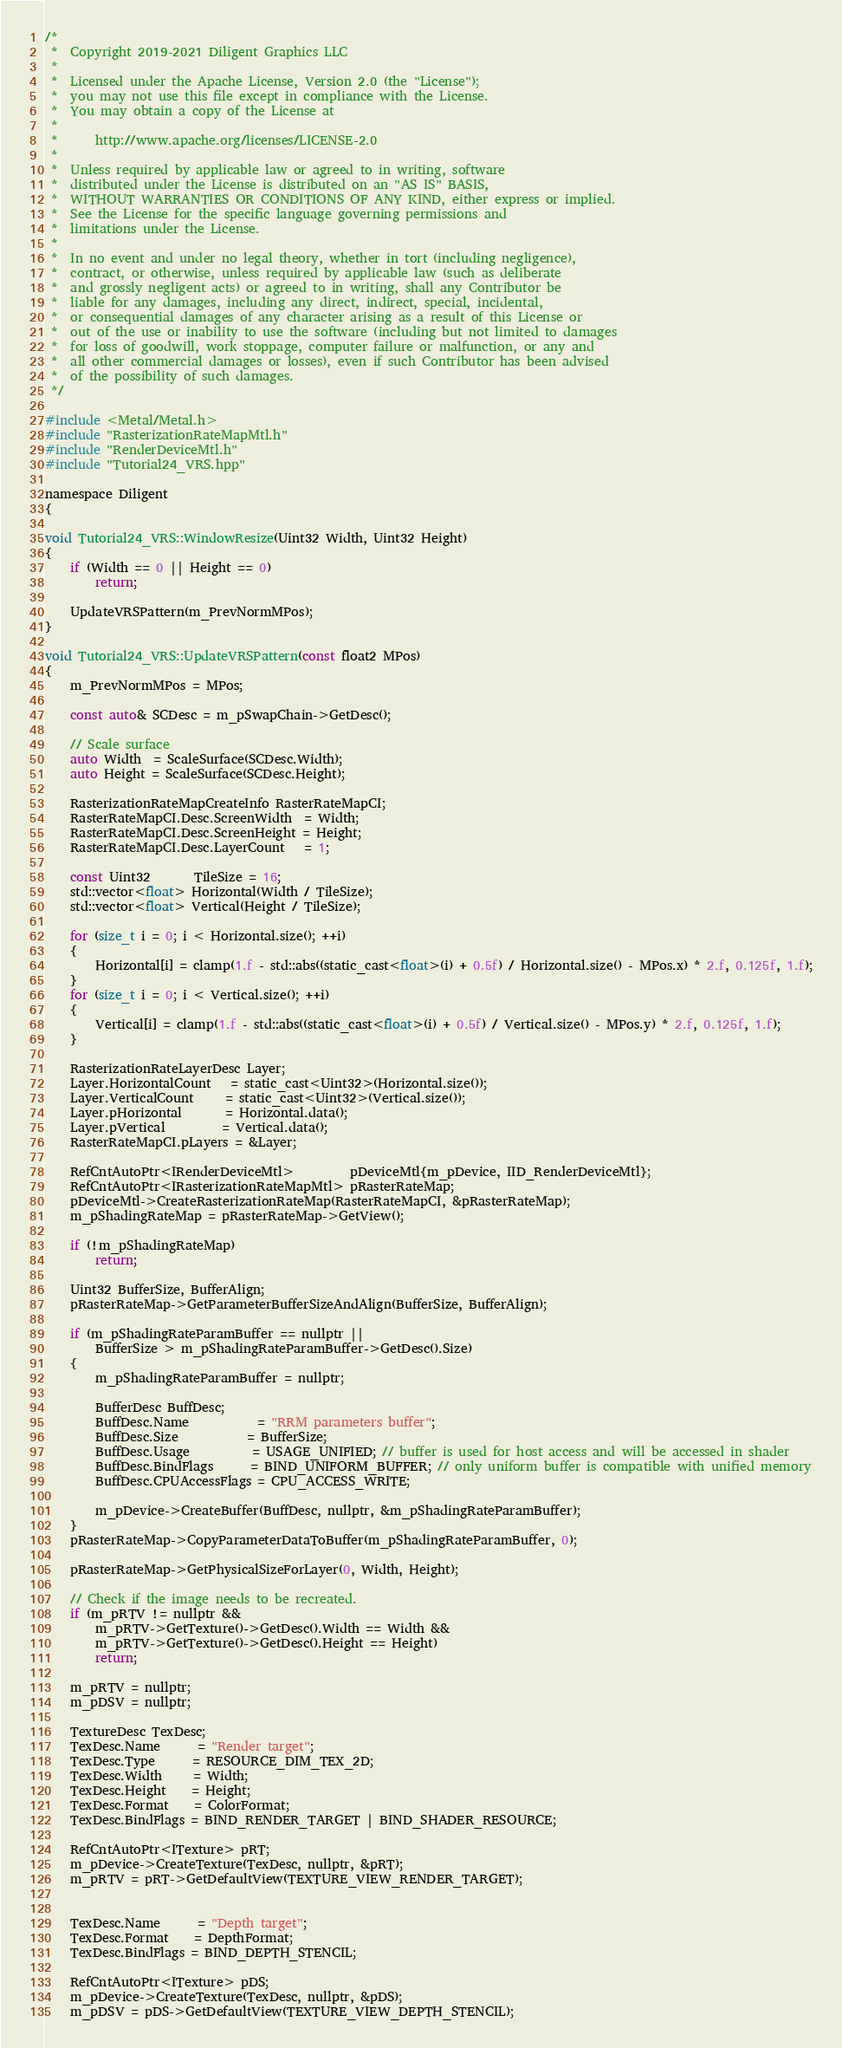Convert code to text. <code><loc_0><loc_0><loc_500><loc_500><_ObjectiveC_>/*
 *  Copyright 2019-2021 Diligent Graphics LLC
 *  
 *  Licensed under the Apache License, Version 2.0 (the "License");
 *  you may not use this file except in compliance with the License.
 *  You may obtain a copy of the License at
 *  
 *      http://www.apache.org/licenses/LICENSE-2.0
 *  
 *  Unless required by applicable law or agreed to in writing, software
 *  distributed under the License is distributed on an "AS IS" BASIS,
 *  WITHOUT WARRANTIES OR CONDITIONS OF ANY KIND, either express or implied.
 *  See the License for the specific language governing permissions and
 *  limitations under the License.
 *
 *  In no event and under no legal theory, whether in tort (including negligence), 
 *  contract, or otherwise, unless required by applicable law (such as deliberate 
 *  and grossly negligent acts) or agreed to in writing, shall any Contributor be
 *  liable for any damages, including any direct, indirect, special, incidental, 
 *  or consequential damages of any character arising as a result of this License or 
 *  out of the use or inability to use the software (including but not limited to damages 
 *  for loss of goodwill, work stoppage, computer failure or malfunction, or any and 
 *  all other commercial damages or losses), even if such Contributor has been advised 
 *  of the possibility of such damages.
 */

#include <Metal/Metal.h>
#include "RasterizationRateMapMtl.h"
#include "RenderDeviceMtl.h"
#include "Tutorial24_VRS.hpp"

namespace Diligent
{

void Tutorial24_VRS::WindowResize(Uint32 Width, Uint32 Height)
{
    if (Width == 0 || Height == 0)
        return;

    UpdateVRSPattern(m_PrevNormMPos);
}

void Tutorial24_VRS::UpdateVRSPattern(const float2 MPos)
{
    m_PrevNormMPos = MPos;

    const auto& SCDesc = m_pSwapChain->GetDesc();

    // Scale surface
    auto Width  = ScaleSurface(SCDesc.Width);
    auto Height = ScaleSurface(SCDesc.Height);

    RasterizationRateMapCreateInfo RasterRateMapCI;
    RasterRateMapCI.Desc.ScreenWidth  = Width;
    RasterRateMapCI.Desc.ScreenHeight = Height;
    RasterRateMapCI.Desc.LayerCount   = 1;
    
    const Uint32       TileSize = 16;
    std::vector<float> Horizontal(Width / TileSize);
    std::vector<float> Vertical(Height / TileSize);

    for (size_t i = 0; i < Horizontal.size(); ++i)
    {
        Horizontal[i] = clamp(1.f - std::abs((static_cast<float>(i) + 0.5f) / Horizontal.size() - MPos.x) * 2.f, 0.125f, 1.f);
    }
    for (size_t i = 0; i < Vertical.size(); ++i)
    {
        Vertical[i] = clamp(1.f - std::abs((static_cast<float>(i) + 0.5f) / Vertical.size() - MPos.y) * 2.f, 0.125f, 1.f);
    }

    RasterizationRateLayerDesc Layer;
    Layer.HorizontalCount   = static_cast<Uint32>(Horizontal.size());
    Layer.VerticalCount     = static_cast<Uint32>(Vertical.size());
    Layer.pHorizontal       = Horizontal.data();
    Layer.pVertical         = Vertical.data();
    RasterRateMapCI.pLayers = &Layer;

    RefCntAutoPtr<IRenderDeviceMtl>         pDeviceMtl{m_pDevice, IID_RenderDeviceMtl};
    RefCntAutoPtr<IRasterizationRateMapMtl> pRasterRateMap;
    pDeviceMtl->CreateRasterizationRateMap(RasterRateMapCI, &pRasterRateMap);
    m_pShadingRateMap = pRasterRateMap->GetView();

    if (!m_pShadingRateMap)
        return;

    Uint32 BufferSize, BufferAlign;
    pRasterRateMap->GetParameterBufferSizeAndAlign(BufferSize, BufferAlign);

    if (m_pShadingRateParamBuffer == nullptr ||
        BufferSize > m_pShadingRateParamBuffer->GetDesc().Size)
    {
        m_pShadingRateParamBuffer = nullptr;

        BufferDesc BuffDesc;
        BuffDesc.Name           = "RRM parameters buffer";
        BuffDesc.Size           = BufferSize;
        BuffDesc.Usage          = USAGE_UNIFIED; // buffer is used for host access and will be accessed in shader
        BuffDesc.BindFlags      = BIND_UNIFORM_BUFFER; // only uniform buffer is compatible with unified memory
        BuffDesc.CPUAccessFlags = CPU_ACCESS_WRITE;

        m_pDevice->CreateBuffer(BuffDesc, nullptr, &m_pShadingRateParamBuffer);
    }
    pRasterRateMap->CopyParameterDataToBuffer(m_pShadingRateParamBuffer, 0);

    pRasterRateMap->GetPhysicalSizeForLayer(0, Width, Height);

    // Check if the image needs to be recreated.
    if (m_pRTV != nullptr &&
        m_pRTV->GetTexture()->GetDesc().Width == Width &&
        m_pRTV->GetTexture()->GetDesc().Height == Height)
        return;

    m_pRTV = nullptr;
    m_pDSV = nullptr;

    TextureDesc TexDesc;
    TexDesc.Name      = "Render target";
    TexDesc.Type      = RESOURCE_DIM_TEX_2D;
    TexDesc.Width     = Width;
    TexDesc.Height    = Height;
    TexDesc.Format    = ColorFormat;
    TexDesc.BindFlags = BIND_RENDER_TARGET | BIND_SHADER_RESOURCE;

    RefCntAutoPtr<ITexture> pRT;
    m_pDevice->CreateTexture(TexDesc, nullptr, &pRT);
    m_pRTV = pRT->GetDefaultView(TEXTURE_VIEW_RENDER_TARGET);


    TexDesc.Name      = "Depth target";
    TexDesc.Format    = DepthFormat;
    TexDesc.BindFlags = BIND_DEPTH_STENCIL;

    RefCntAutoPtr<ITexture> pDS;
    m_pDevice->CreateTexture(TexDesc, nullptr, &pDS);
    m_pDSV = pDS->GetDefaultView(TEXTURE_VIEW_DEPTH_STENCIL);
</code> 